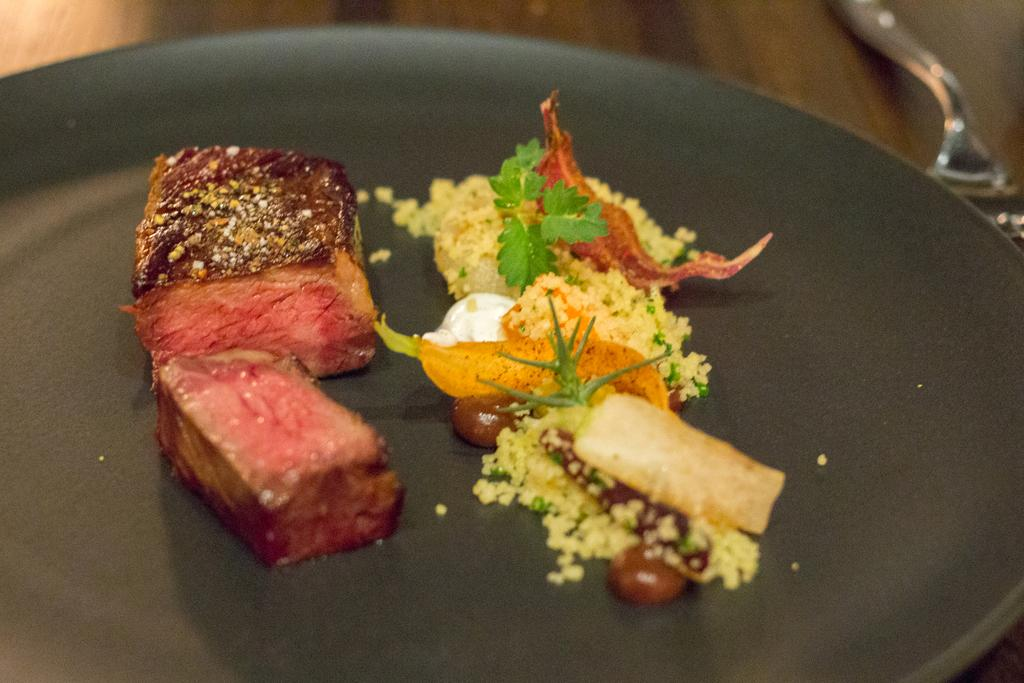What is the main object in the image? There is a pan in the image. What is inside the pan? The pan contains a food item with meat, leaves, and other ingredients. What utensil is visible in the image? There is a fork visible in the image. How many trees are visible in the image? There are no trees visible in the image; it only contains a pan with food and a fork. What type of unit is being measured in the image? There is no unit being measured in the image; it only contains a pan with food and a fork. 